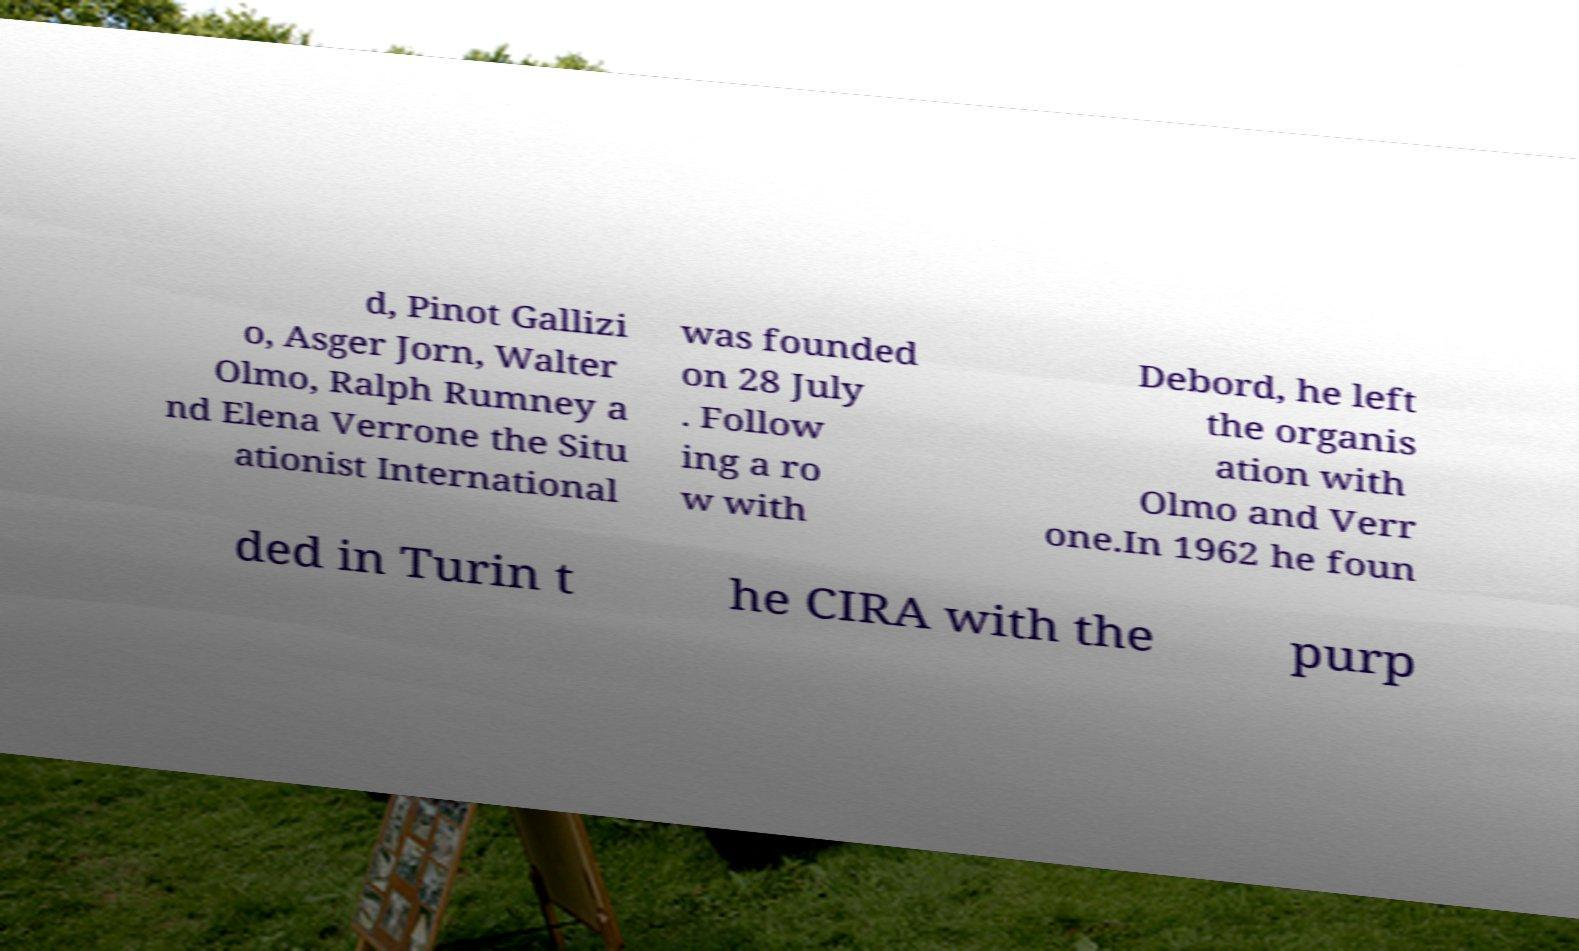What messages or text are displayed in this image? I need them in a readable, typed format. d, Pinot Gallizi o, Asger Jorn, Walter Olmo, Ralph Rumney a nd Elena Verrone the Situ ationist International was founded on 28 July . Follow ing a ro w with Debord, he left the organis ation with Olmo and Verr one.In 1962 he foun ded in Turin t he CIRA with the purp 